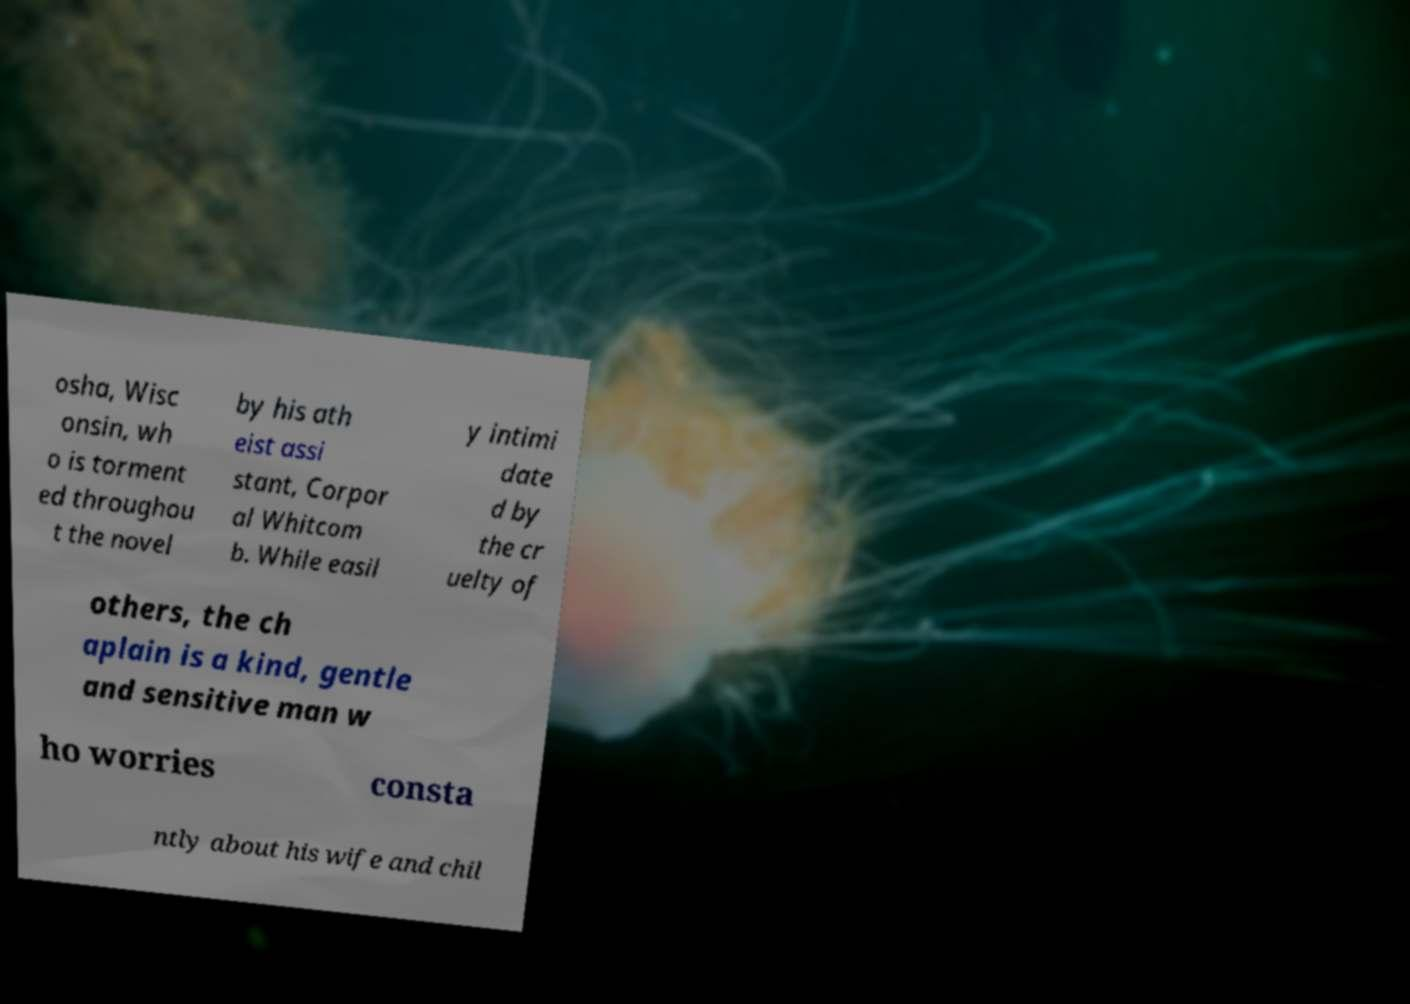Can you accurately transcribe the text from the provided image for me? osha, Wisc onsin, wh o is torment ed throughou t the novel by his ath eist assi stant, Corpor al Whitcom b. While easil y intimi date d by the cr uelty of others, the ch aplain is a kind, gentle and sensitive man w ho worries consta ntly about his wife and chil 